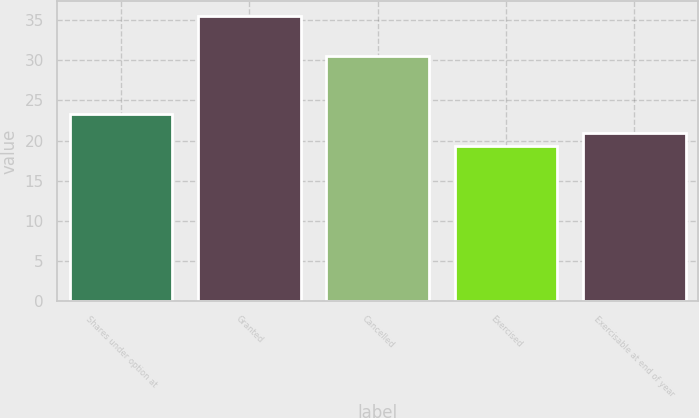Convert chart to OTSL. <chart><loc_0><loc_0><loc_500><loc_500><bar_chart><fcel>Shares under option at<fcel>Granted<fcel>Cancelled<fcel>Exercised<fcel>Exercisable at end of year<nl><fcel>23.28<fcel>35.55<fcel>30.55<fcel>19.28<fcel>20.91<nl></chart> 